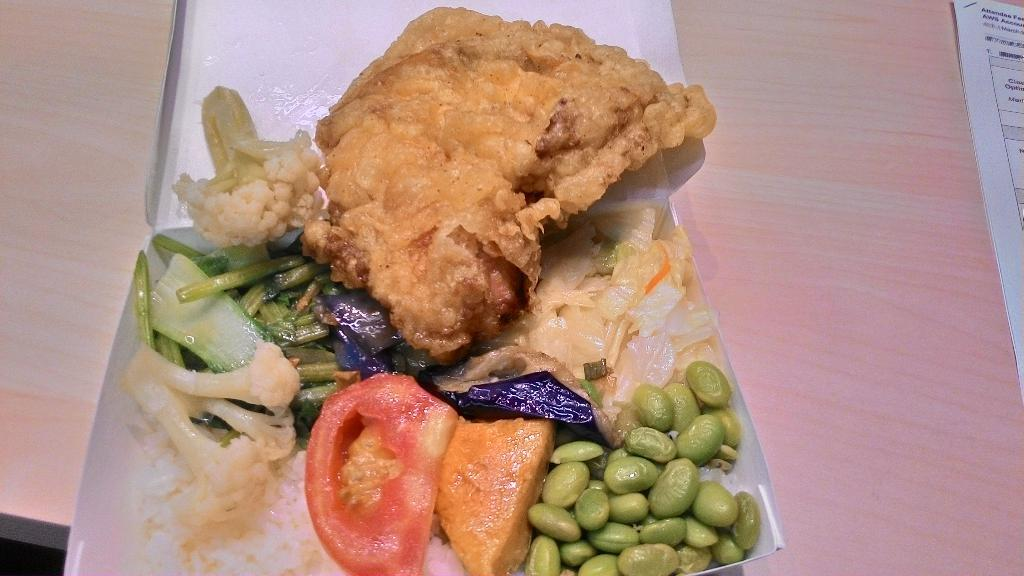What object is present in the image that can hold items? There is a box in the image that can hold items. What is inside the box in the image? The box contains different types of food. What is located on the right side of the image? There are papers on the right side of the image. What can be seen on the papers in the image? Writing is visible on the papers. What type of floor can be seen in the image? There is no floor visible in the image; it only shows a box, papers, and writing. 